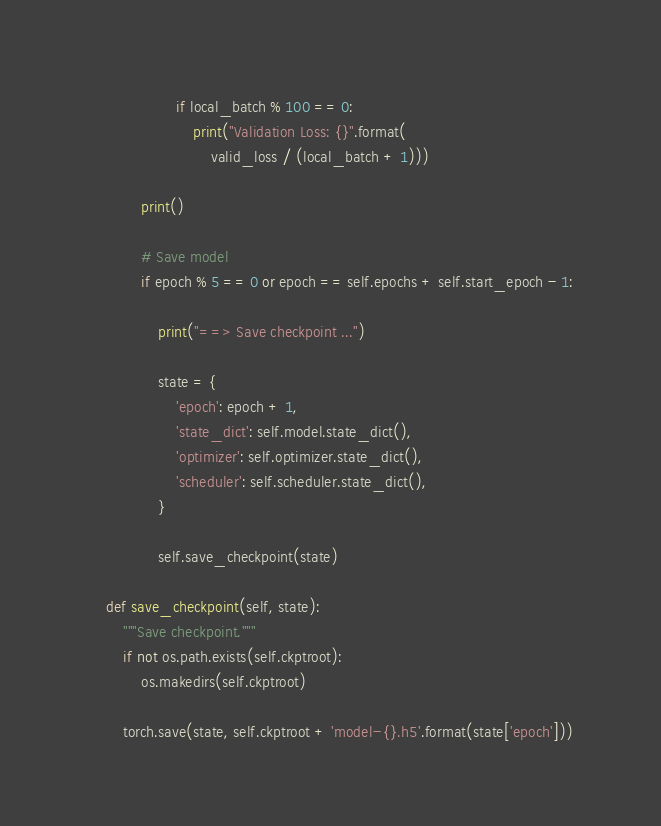Convert code to text. <code><loc_0><loc_0><loc_500><loc_500><_Python_>                    if local_batch % 100 == 0:
                        print("Validation Loss: {}".format(
                            valid_loss / (local_batch + 1)))

            print()

            # Save model
            if epoch % 5 == 0 or epoch == self.epochs + self.start_epoch - 1:

                print("==> Save checkpoint ...")

                state = {
                    'epoch': epoch + 1,
                    'state_dict': self.model.state_dict(),
                    'optimizer': self.optimizer.state_dict(),
                    'scheduler': self.scheduler.state_dict(),
                }

                self.save_checkpoint(state)

    def save_checkpoint(self, state):
        """Save checkpoint."""
        if not os.path.exists(self.ckptroot):
            os.makedirs(self.ckptroot)

        torch.save(state, self.ckptroot + 'model-{}.h5'.format(state['epoch']))
</code> 